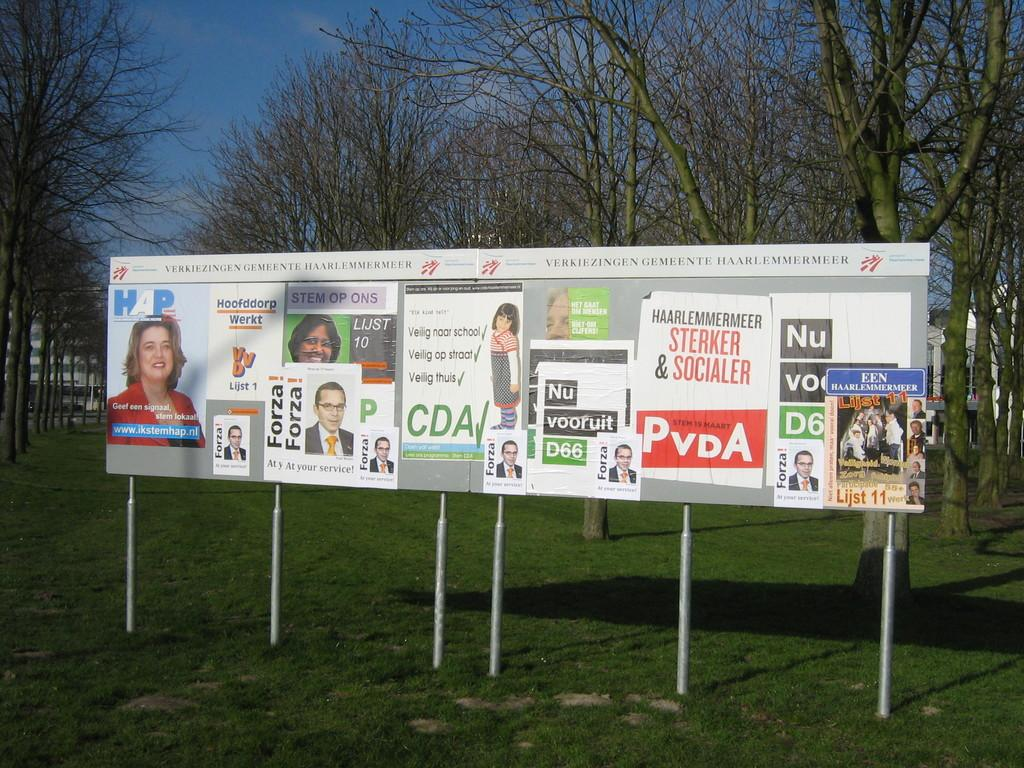<image>
Describe the image concisely. Billboard showing a woman in red titled "Geed een signaal". 